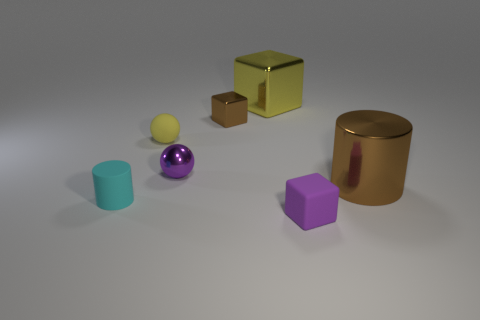How many cyan objects are either tiny rubber things or metal blocks? In the image, I identified one cyan-colored object; it looks like a small rubber cup. So, there is one cyan object that could be categorized as a tiny rubber thing. There are no metal blocks that are cyan in color. 